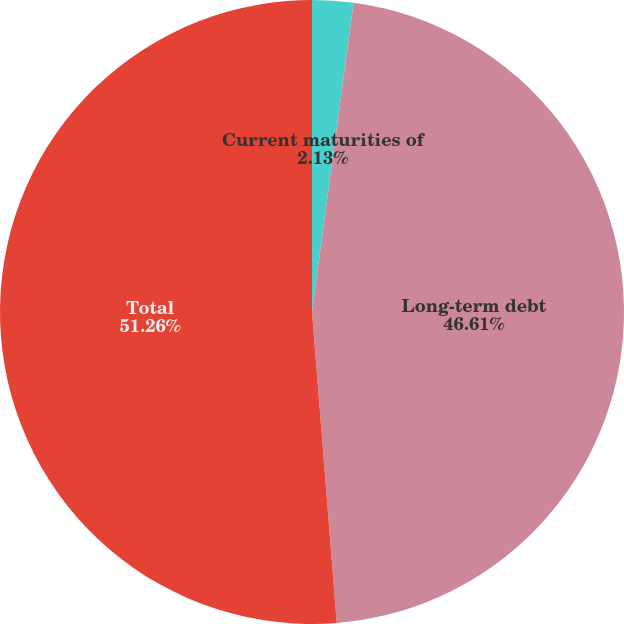Convert chart to OTSL. <chart><loc_0><loc_0><loc_500><loc_500><pie_chart><fcel>Current maturities of<fcel>Long-term debt<fcel>Total<nl><fcel>2.13%<fcel>46.61%<fcel>51.27%<nl></chart> 